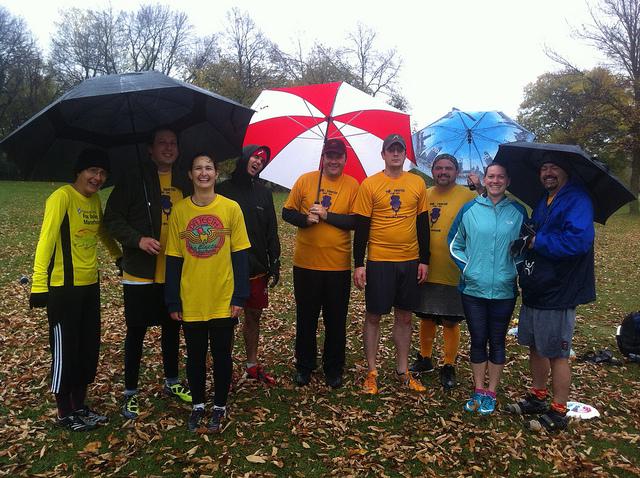How many umbrellas are in the design of an animal?
Quick response, please. 0. What is on the blue umbrella?
Concise answer only. Nothing. How many black umbrellas are shown?
Keep it brief. 2. How many people are in yellow shirts?
Answer briefly. 3. What kind of shoes are these people wearing?
Quick response, please. Tennis shoes. The weather is clear?
Keep it brief. No. What kind of gathering is this?
Answer briefly. Family. 